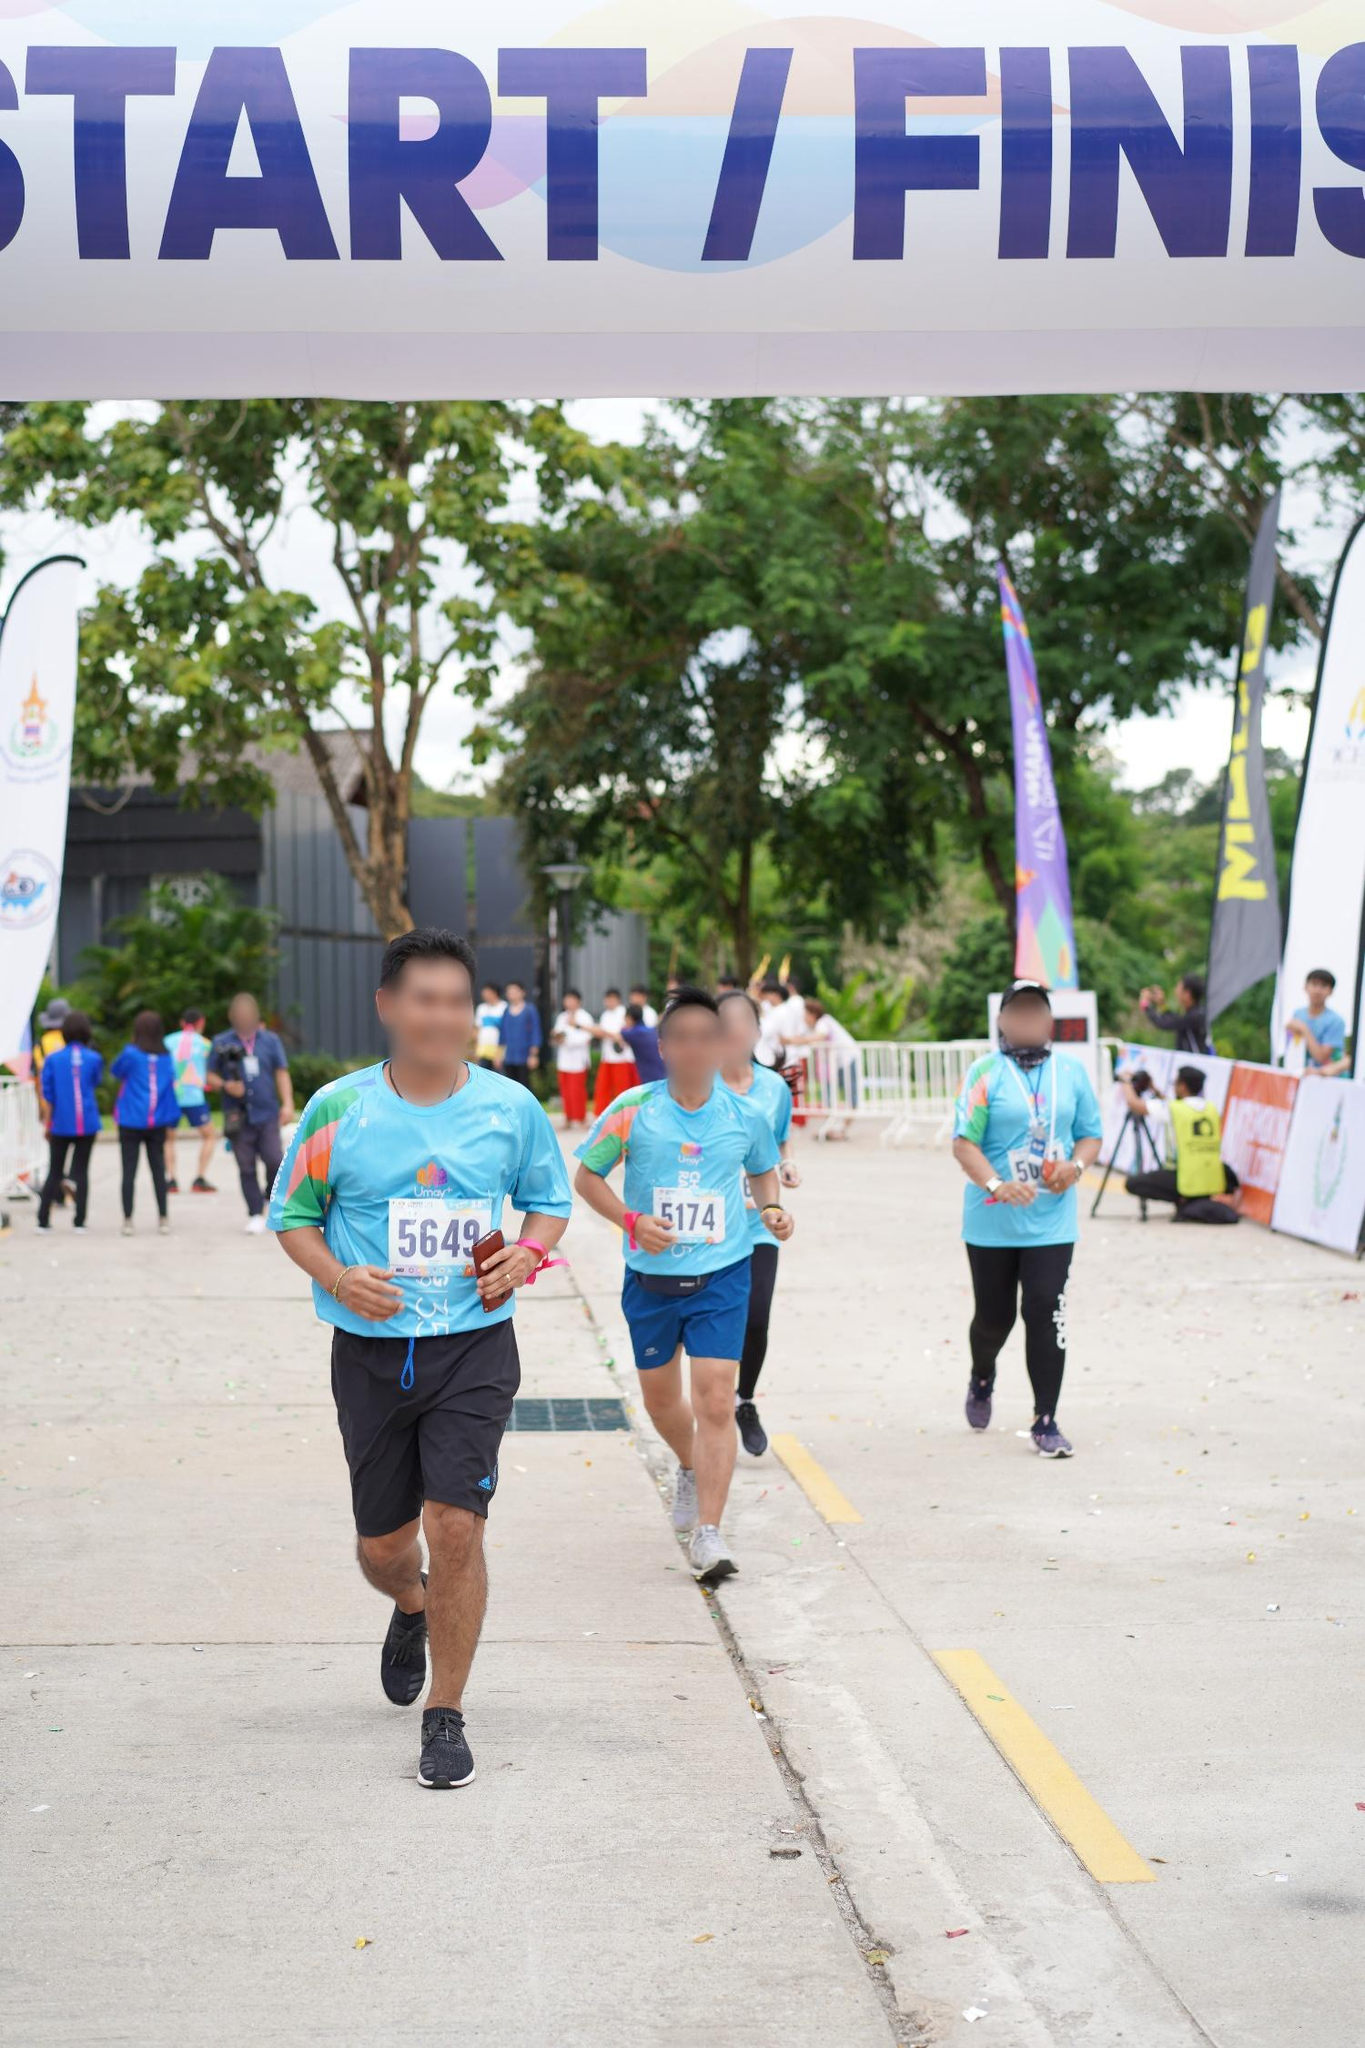What do you think is going on in this snapshot? The image captures an energetic moment at a race event. In the foreground, runners are seen crossing a large white banner marked 'START/FINISH,' signaling either the beginning or end of their race. The text on the banner is prominently displayed in blue. Vibrant purple and yellow flags frame the racing area, adding to the festive atmosphere. The majority of the runners are wearing blue shirts with individual race numbers. The runner closest to the camera is wearing a number '5649', and just behind him, another participant wears '5174'. The scene is set against a peaceful backdrop with trees and a cloudy sky, creating a striking contrast between the lively competition and serene nature. Volunteers and other participants can be seen in the background, emphasizing the communal spirit of the event. 